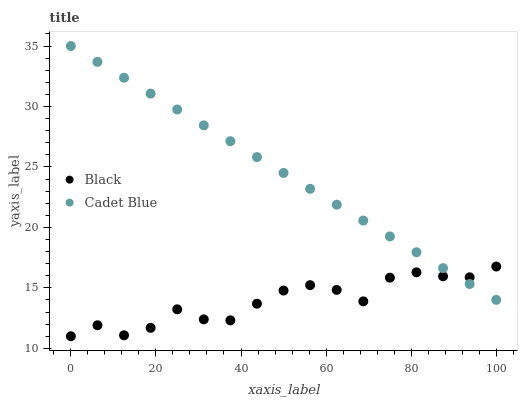Does Black have the minimum area under the curve?
Answer yes or no. Yes. Does Cadet Blue have the maximum area under the curve?
Answer yes or no. Yes. Does Black have the maximum area under the curve?
Answer yes or no. No. Is Cadet Blue the smoothest?
Answer yes or no. Yes. Is Black the roughest?
Answer yes or no. Yes. Is Black the smoothest?
Answer yes or no. No. Does Black have the lowest value?
Answer yes or no. Yes. Does Cadet Blue have the highest value?
Answer yes or no. Yes. Does Black have the highest value?
Answer yes or no. No. Does Cadet Blue intersect Black?
Answer yes or no. Yes. Is Cadet Blue less than Black?
Answer yes or no. No. Is Cadet Blue greater than Black?
Answer yes or no. No. 